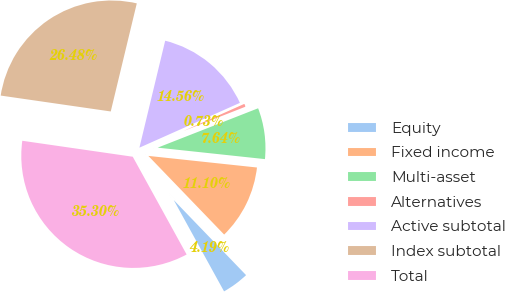<chart> <loc_0><loc_0><loc_500><loc_500><pie_chart><fcel>Equity<fcel>Fixed income<fcel>Multi-asset<fcel>Alternatives<fcel>Active subtotal<fcel>Index subtotal<fcel>Total<nl><fcel>4.19%<fcel>11.1%<fcel>7.64%<fcel>0.73%<fcel>14.56%<fcel>26.48%<fcel>35.3%<nl></chart> 